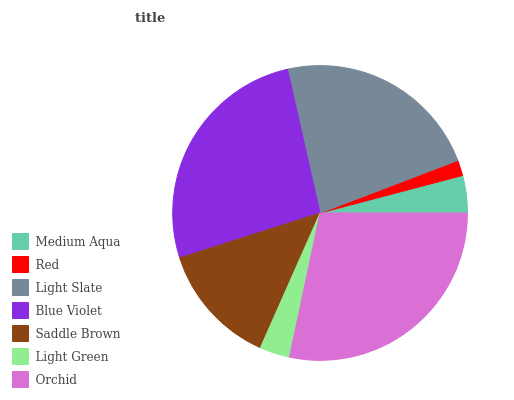Is Red the minimum?
Answer yes or no. Yes. Is Orchid the maximum?
Answer yes or no. Yes. Is Light Slate the minimum?
Answer yes or no. No. Is Light Slate the maximum?
Answer yes or no. No. Is Light Slate greater than Red?
Answer yes or no. Yes. Is Red less than Light Slate?
Answer yes or no. Yes. Is Red greater than Light Slate?
Answer yes or no. No. Is Light Slate less than Red?
Answer yes or no. No. Is Saddle Brown the high median?
Answer yes or no. Yes. Is Saddle Brown the low median?
Answer yes or no. Yes. Is Medium Aqua the high median?
Answer yes or no. No. Is Medium Aqua the low median?
Answer yes or no. No. 